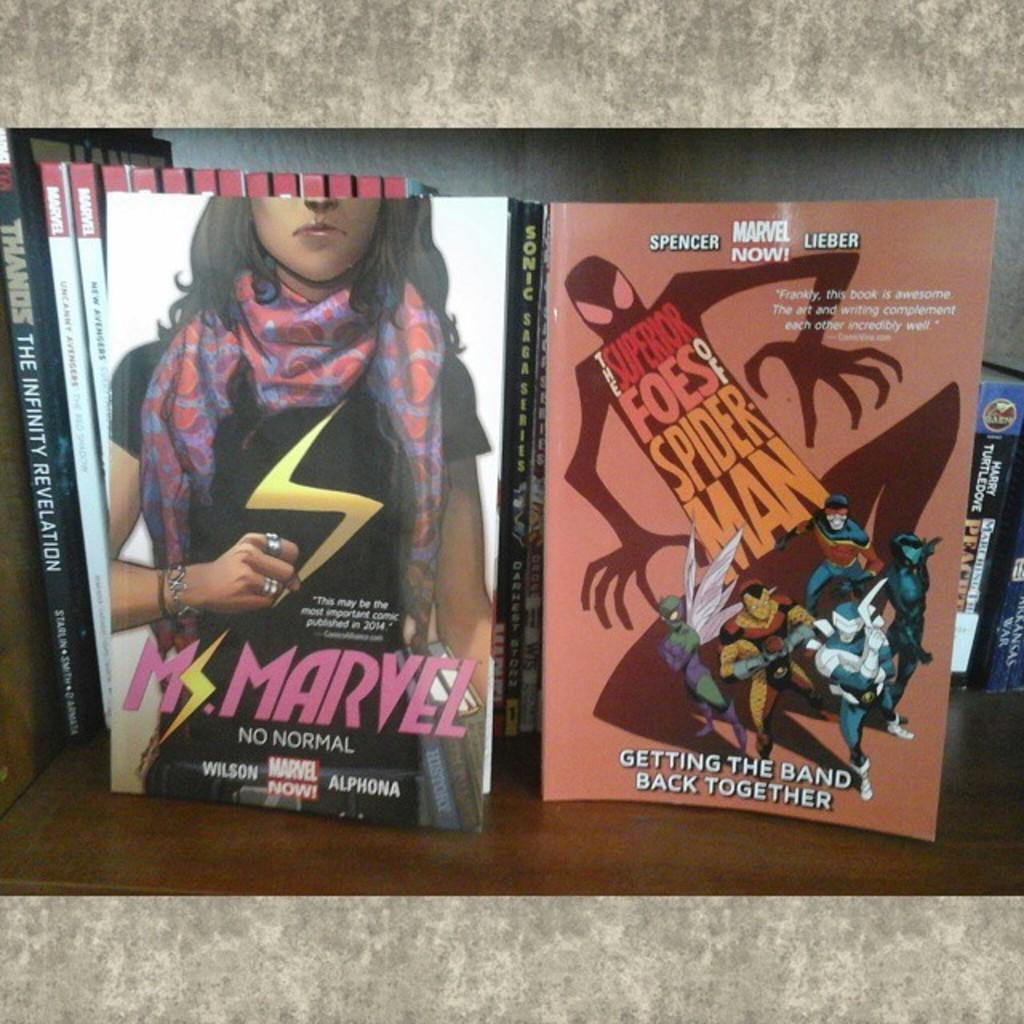What is the superhero name of the left magazine?
Your answer should be compact. Ms. marvel. Who wrote the book on the right?
Ensure brevity in your answer.  Spencer lieber. 